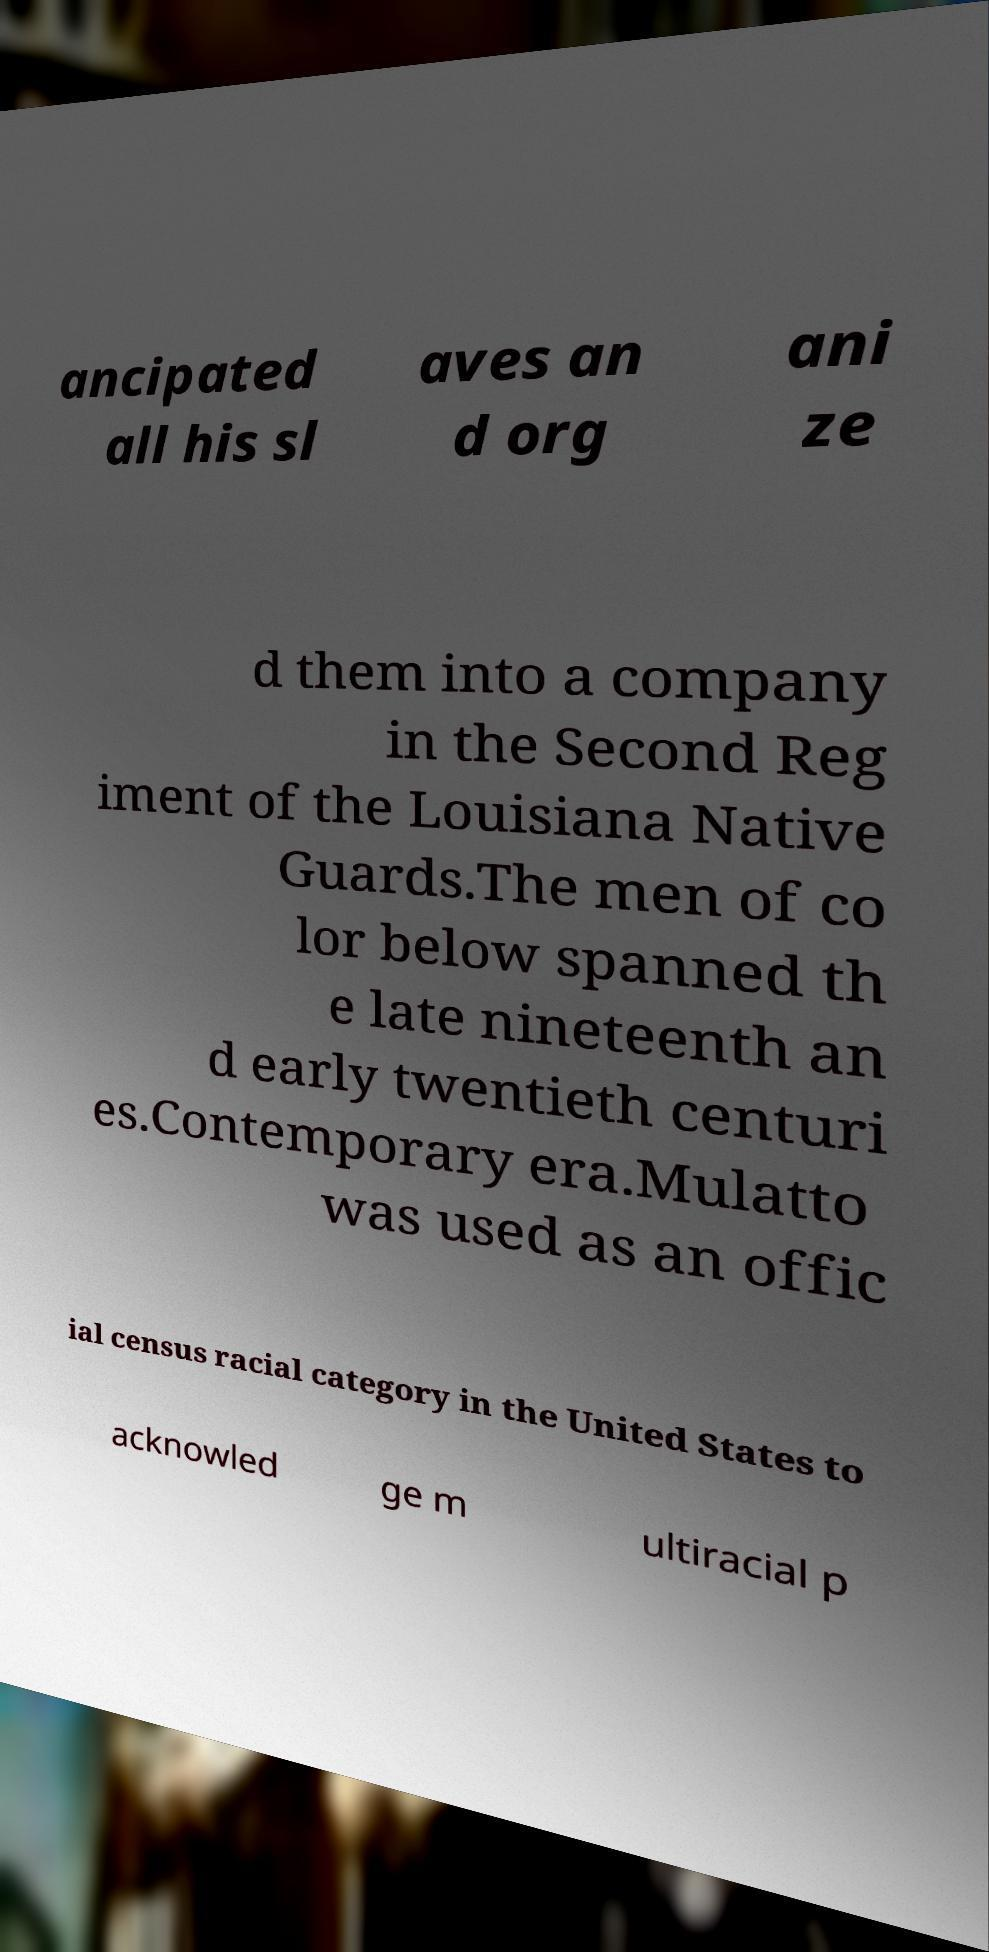Could you extract and type out the text from this image? ancipated all his sl aves an d org ani ze d them into a company in the Second Reg iment of the Louisiana Native Guards.The men of co lor below spanned th e late nineteenth an d early twentieth centuri es.Contemporary era.Mulatto was used as an offic ial census racial category in the United States to acknowled ge m ultiracial p 